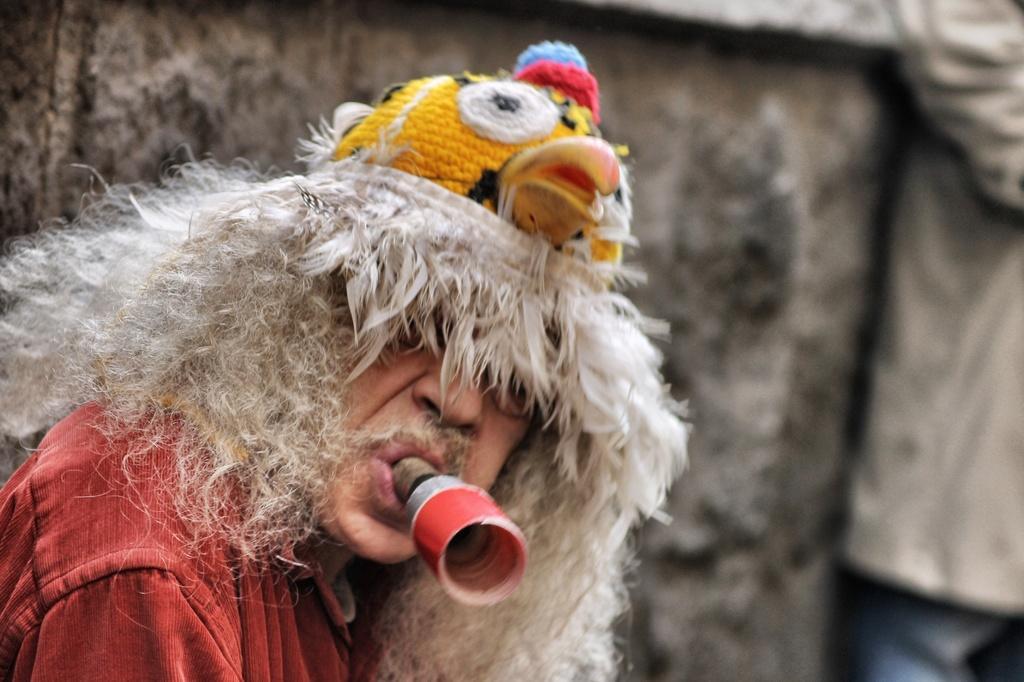Please provide a concise description of this image. In this image there is a man who has a whistle in his mouth. In the background there is a wall. 